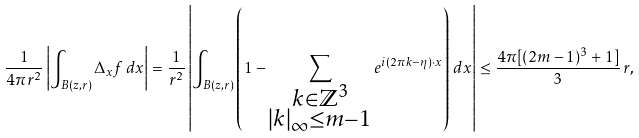<formula> <loc_0><loc_0><loc_500><loc_500>\frac { 1 } { 4 \pi r ^ { 2 } } \left | \int _ { B ( z , r ) } \Delta _ { x } f \, d x \right | = \frac { 1 } { r ^ { 2 } } \left | \int _ { B ( z , r ) } \left ( 1 - \sum _ { \substack { k \in \mathbb { Z } ^ { 3 } \\ | k | _ { \infty } \leq m - 1 } } e ^ { i ( 2 \pi k - \eta ) \cdot x } \right ) \, d x \right | \leq \frac { 4 \pi [ ( 2 m - 1 ) ^ { 3 } + 1 ] } { 3 } \, r ,</formula> 